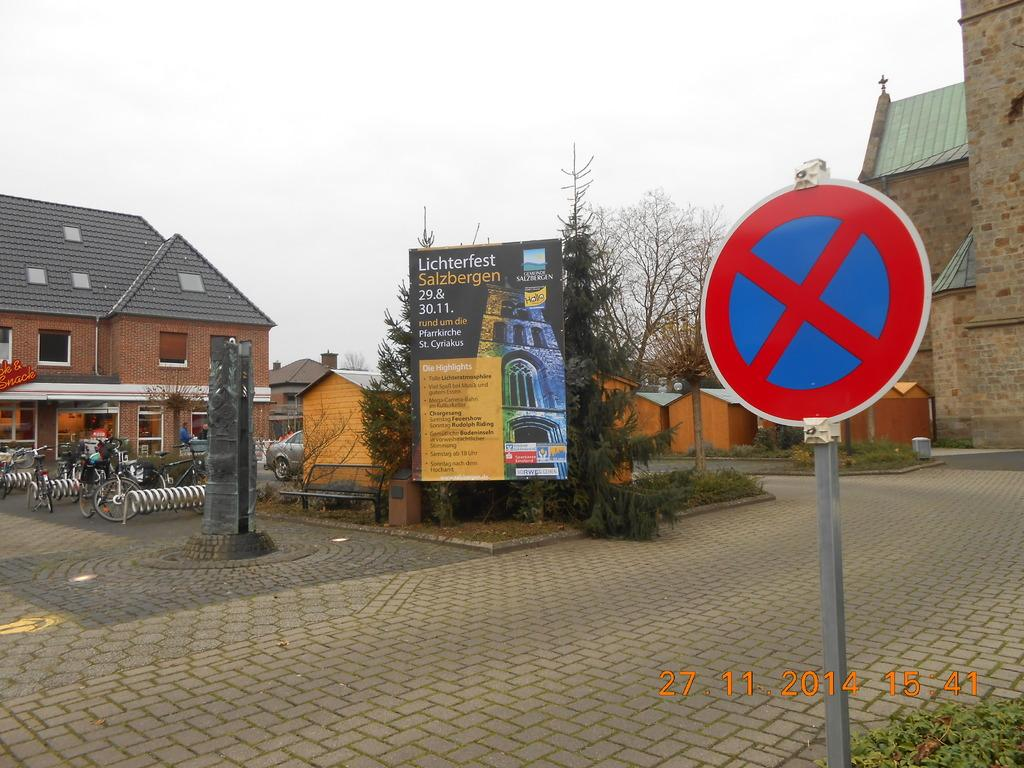<image>
Relay a brief, clear account of the picture shown. A sign in a town square is advertising the Lichterfest for the 29th and 30th. 